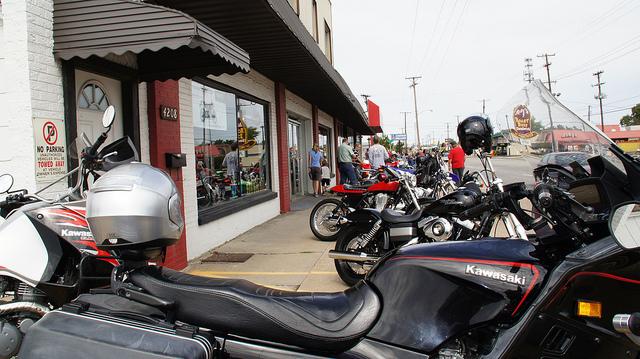What color is the helmet on the closet bike?
Write a very short answer. Silver. Are you allowed to park in front of the store?
Keep it brief. Yes. Is a fast food restaurant visible in this picture?
Answer briefly. Yes. 